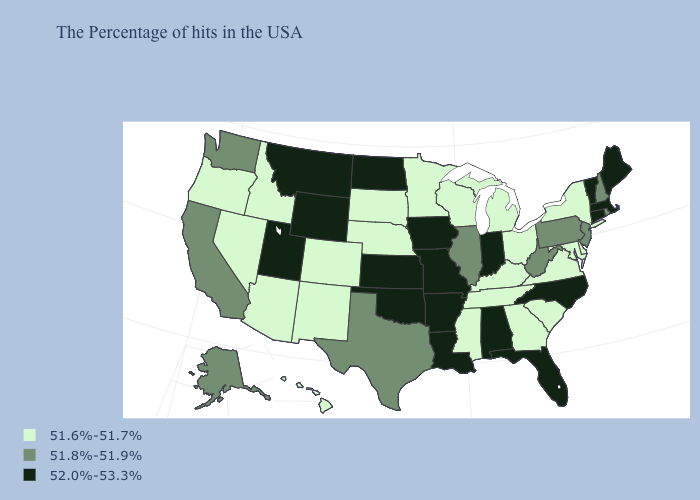What is the value of Arkansas?
Short answer required. 52.0%-53.3%. Is the legend a continuous bar?
Be succinct. No. What is the highest value in states that border Iowa?
Quick response, please. 52.0%-53.3%. Does the map have missing data?
Write a very short answer. No. Name the states that have a value in the range 51.6%-51.7%?
Keep it brief. New York, Delaware, Maryland, Virginia, South Carolina, Ohio, Georgia, Michigan, Kentucky, Tennessee, Wisconsin, Mississippi, Minnesota, Nebraska, South Dakota, Colorado, New Mexico, Arizona, Idaho, Nevada, Oregon, Hawaii. What is the value of North Dakota?
Short answer required. 52.0%-53.3%. What is the lowest value in the West?
Short answer required. 51.6%-51.7%. What is the highest value in states that border Utah?
Write a very short answer. 52.0%-53.3%. Does Missouri have the highest value in the USA?
Concise answer only. Yes. What is the highest value in the USA?
Quick response, please. 52.0%-53.3%. Among the states that border North Dakota , which have the highest value?
Short answer required. Montana. Does Missouri have the highest value in the MidWest?
Write a very short answer. Yes. Name the states that have a value in the range 52.0%-53.3%?
Write a very short answer. Maine, Massachusetts, Vermont, Connecticut, North Carolina, Florida, Indiana, Alabama, Louisiana, Missouri, Arkansas, Iowa, Kansas, Oklahoma, North Dakota, Wyoming, Utah, Montana. Name the states that have a value in the range 51.8%-51.9%?
Concise answer only. Rhode Island, New Hampshire, New Jersey, Pennsylvania, West Virginia, Illinois, Texas, California, Washington, Alaska. 